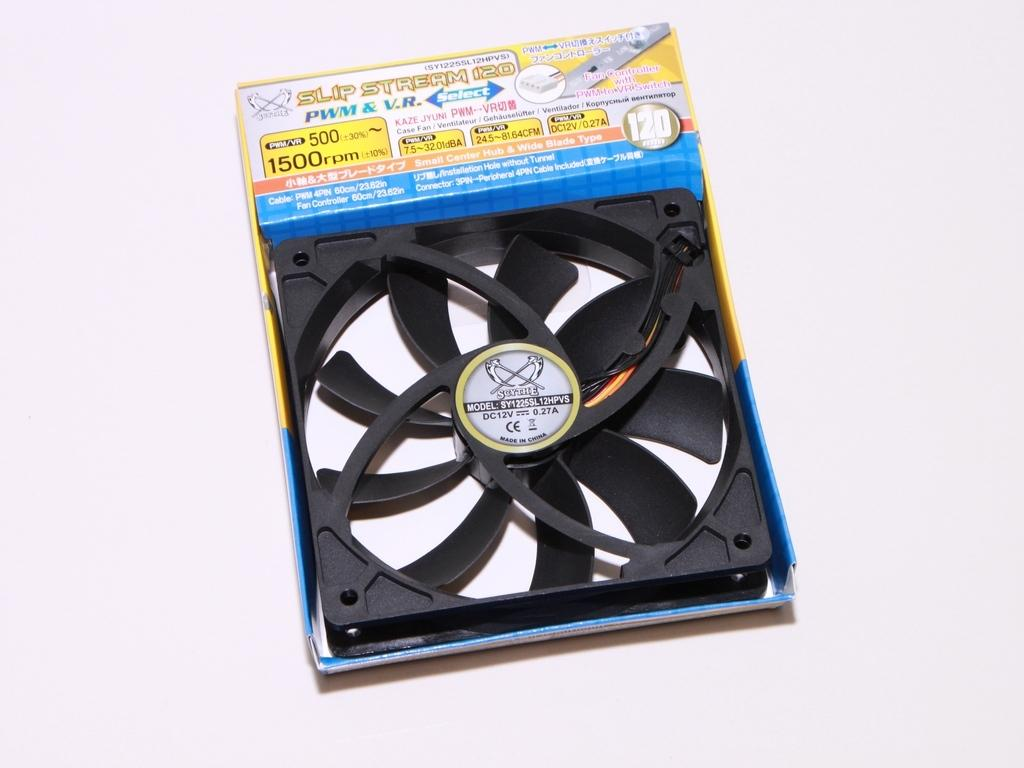What is the main object in the image? There is an exhaust fan in the image. Where is the exhaust fan located? The exhaust fan is inside a box. What is the box resting on? The box is on a white object. How many bikes are parked next to the exhaust fan in the image? There are no bikes present in the image. Can you tell me the stretch of the exhaust fan in the image? The exhaust fan does not have a stretch, as it is a stationary object. 